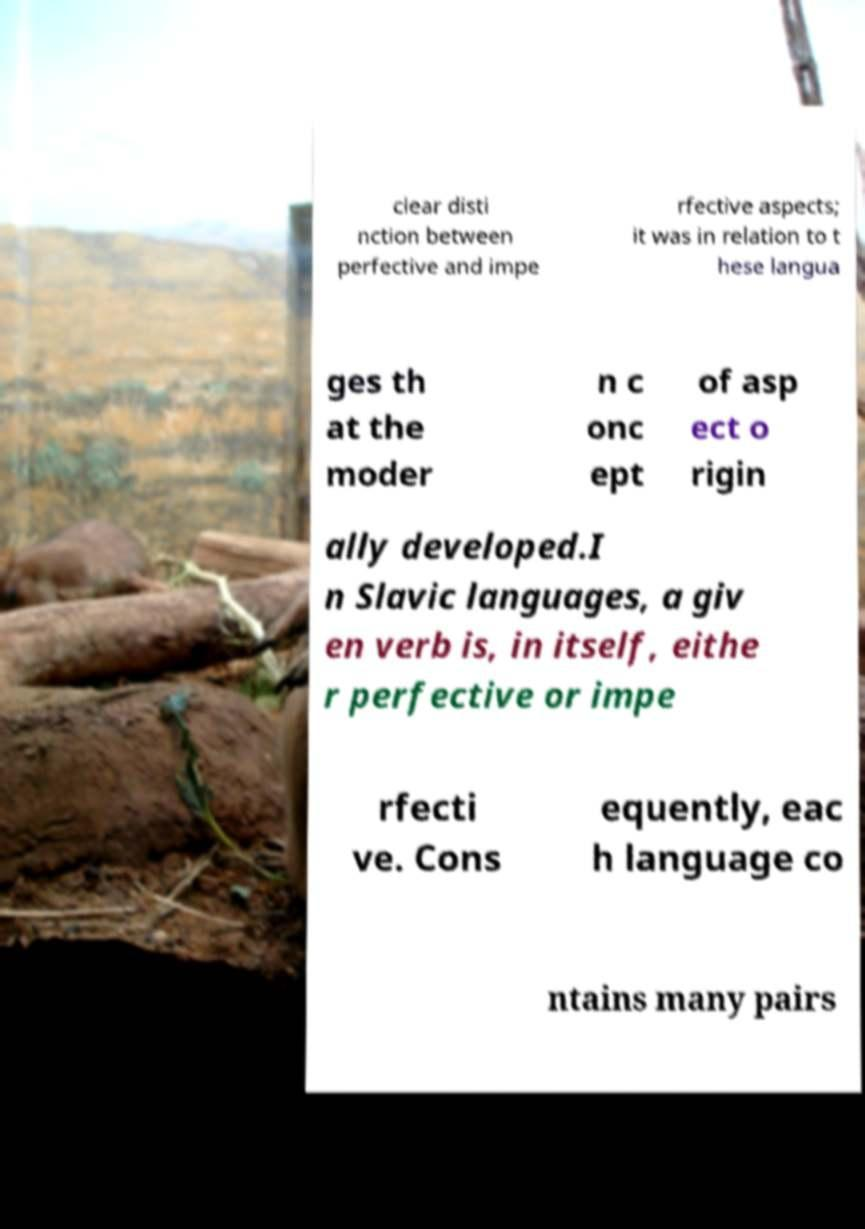What messages or text are displayed in this image? I need them in a readable, typed format. clear disti nction between perfective and impe rfective aspects; it was in relation to t hese langua ges th at the moder n c onc ept of asp ect o rigin ally developed.I n Slavic languages, a giv en verb is, in itself, eithe r perfective or impe rfecti ve. Cons equently, eac h language co ntains many pairs 